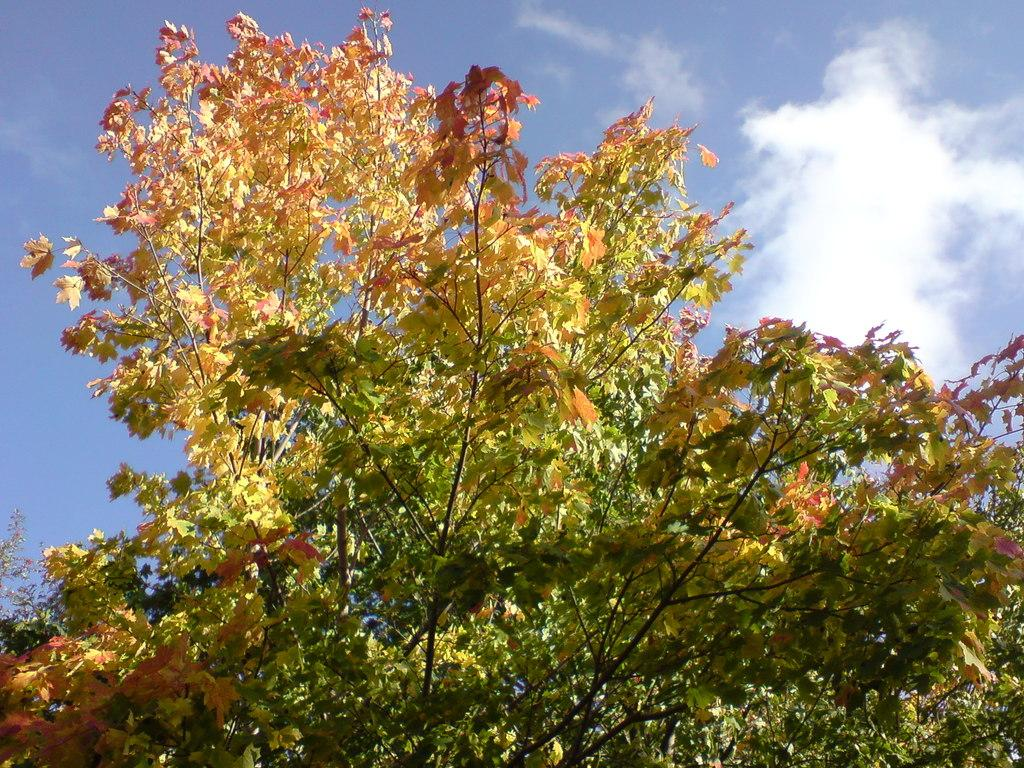What is the main subject of the picture? The main subject of the picture is a tree. What color are the leaves on the tree? The tree has green leaves, and some leaves are yellow and red. What can be seen in the background of the picture? There is a sky visible in the background. What is the condition of the sky in the picture? Clouds are present in the sky. What is the name of the beetle crawling on the tree in the image? There is no beetle present on the tree in the image. What type of sky is depicted in the image? The sky is not specified in the image, only that clouds are present. 